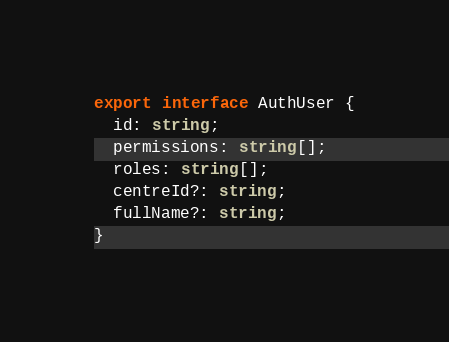<code> <loc_0><loc_0><loc_500><loc_500><_TypeScript_>export interface AuthUser {
  id: string;
  permissions: string[];
  roles: string[];
  centreId?: string;
  fullName?: string;
}
</code> 